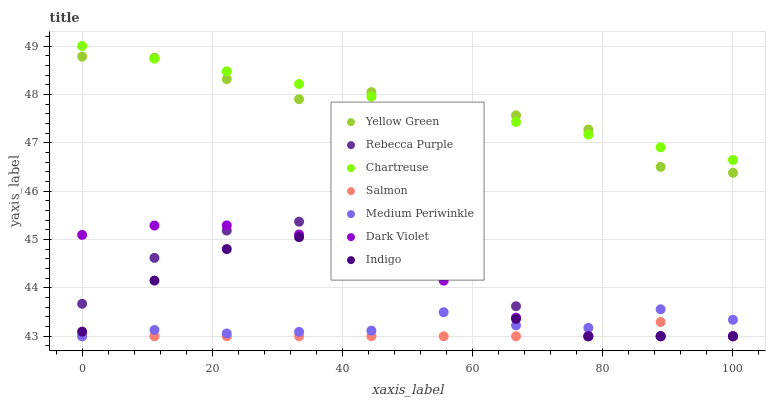Does Salmon have the minimum area under the curve?
Answer yes or no. Yes. Does Chartreuse have the maximum area under the curve?
Answer yes or no. Yes. Does Yellow Green have the minimum area under the curve?
Answer yes or no. No. Does Yellow Green have the maximum area under the curve?
Answer yes or no. No. Is Chartreuse the smoothest?
Answer yes or no. Yes. Is Yellow Green the roughest?
Answer yes or no. Yes. Is Salmon the smoothest?
Answer yes or no. No. Is Salmon the roughest?
Answer yes or no. No. Does Indigo have the lowest value?
Answer yes or no. Yes. Does Yellow Green have the lowest value?
Answer yes or no. No. Does Chartreuse have the highest value?
Answer yes or no. Yes. Does Yellow Green have the highest value?
Answer yes or no. No. Is Medium Periwinkle less than Yellow Green?
Answer yes or no. Yes. Is Yellow Green greater than Medium Periwinkle?
Answer yes or no. Yes. Does Indigo intersect Salmon?
Answer yes or no. Yes. Is Indigo less than Salmon?
Answer yes or no. No. Is Indigo greater than Salmon?
Answer yes or no. No. Does Medium Periwinkle intersect Yellow Green?
Answer yes or no. No. 